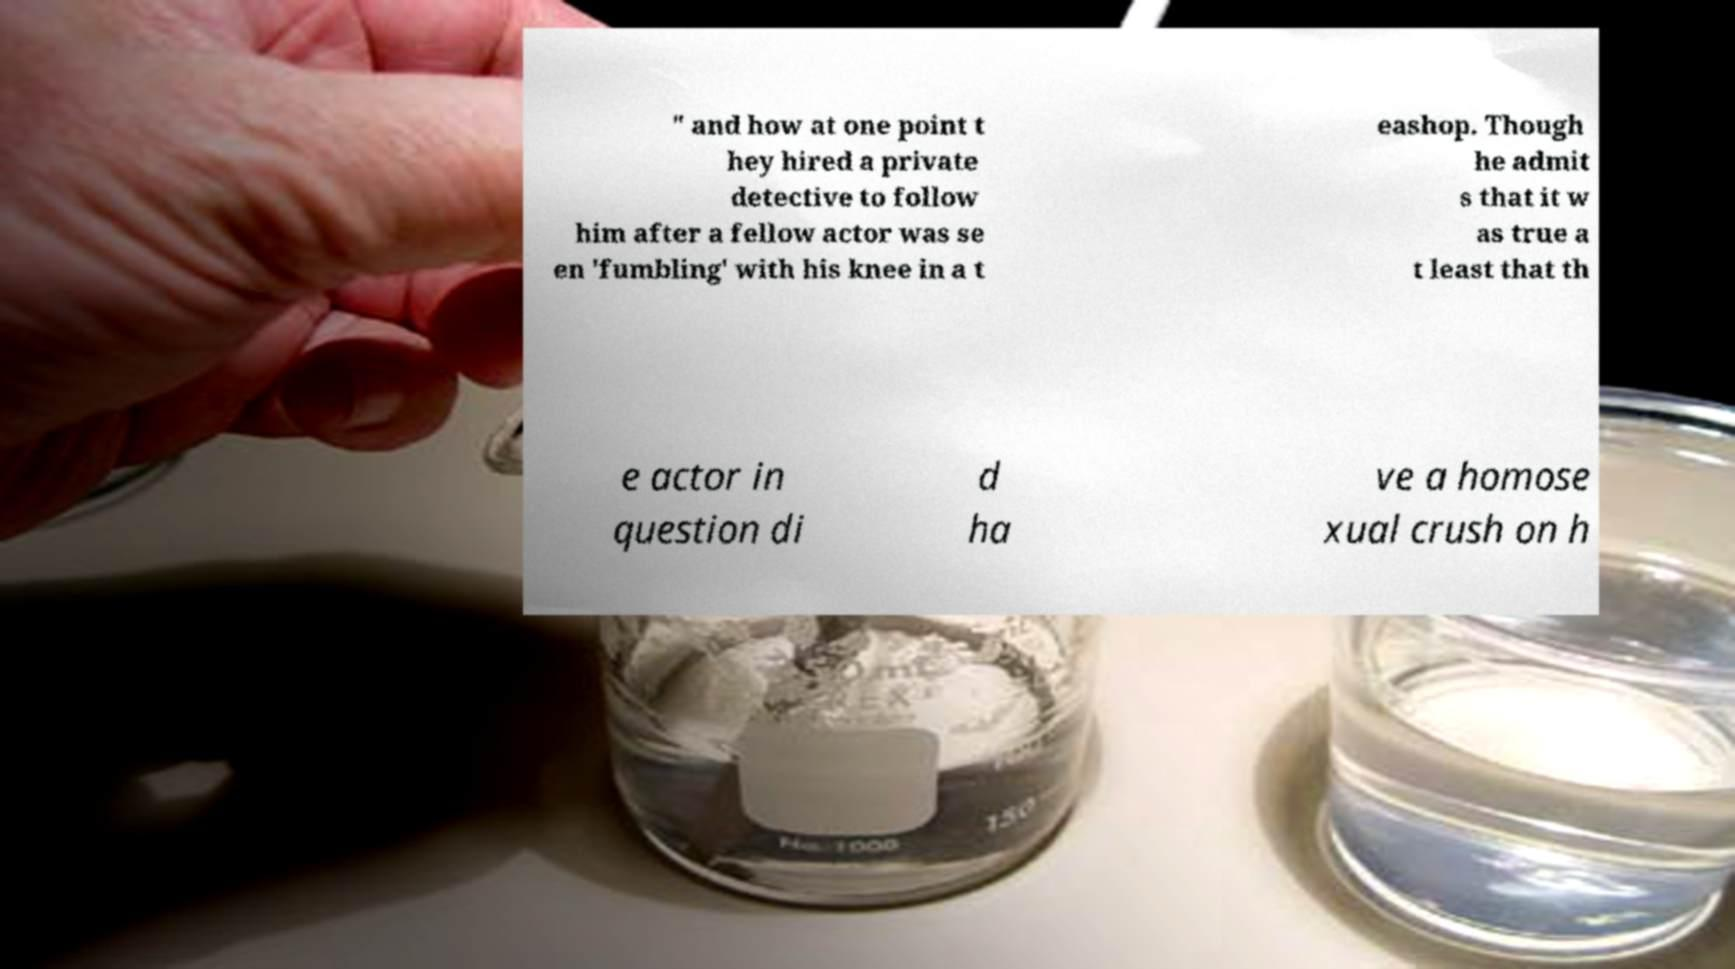I need the written content from this picture converted into text. Can you do that? " and how at one point t hey hired a private detective to follow him after a fellow actor was se en 'fumbling' with his knee in a t eashop. Though he admit s that it w as true a t least that th e actor in question di d ha ve a homose xual crush on h 